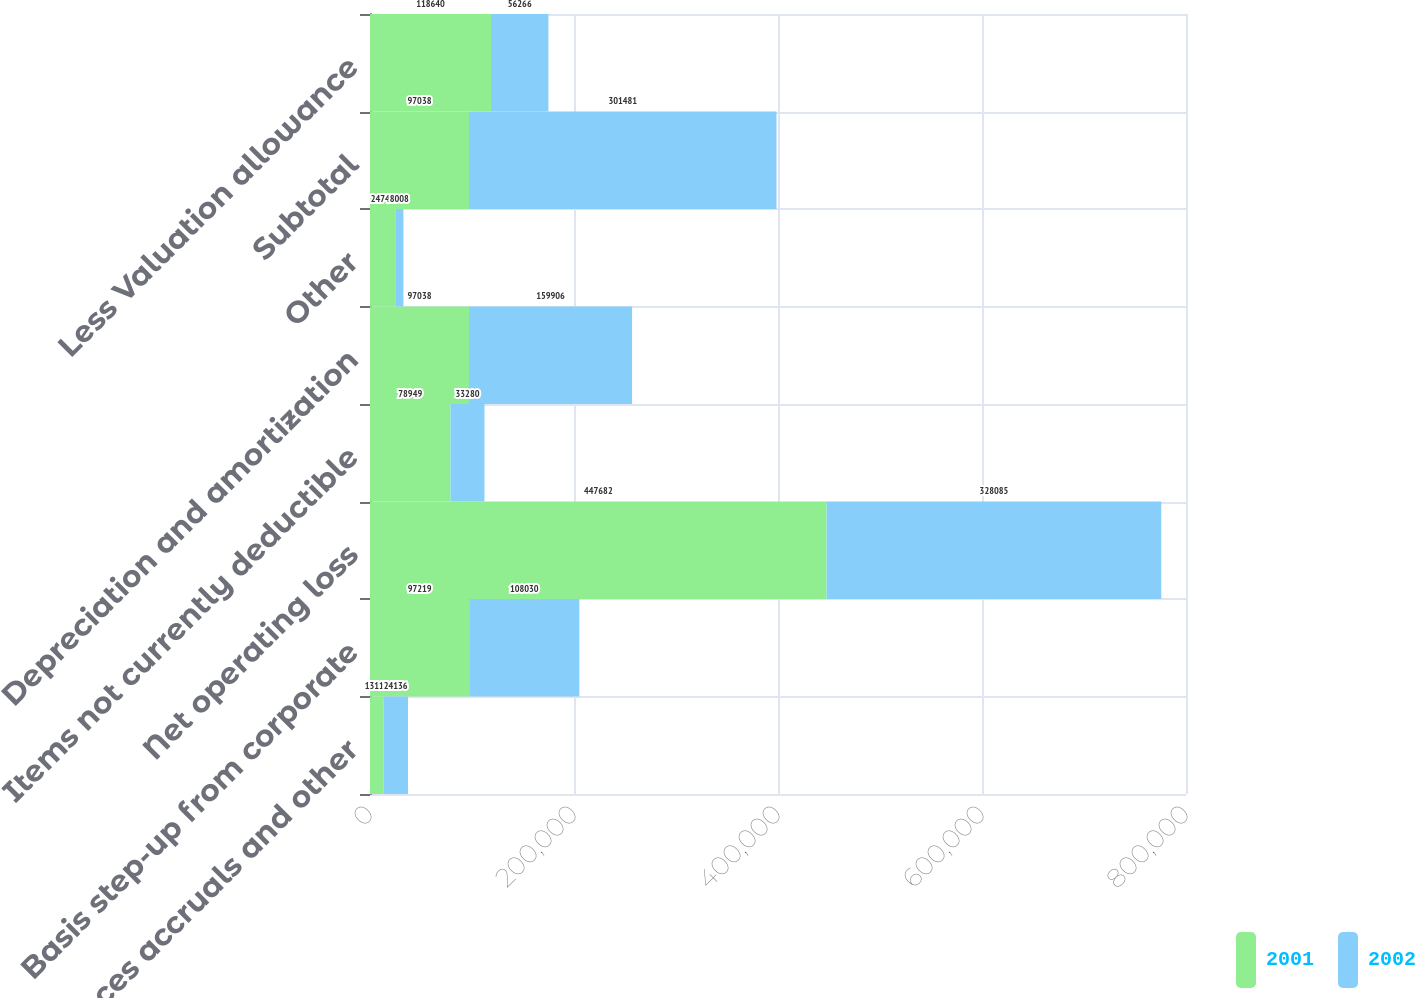Convert chart. <chart><loc_0><loc_0><loc_500><loc_500><stacked_bar_chart><ecel><fcel>Allowances accruals and other<fcel>Basis step-up from corporate<fcel>Net operating loss<fcel>Items not currently deductible<fcel>Depreciation and amortization<fcel>Other<fcel>Subtotal<fcel>Less Valuation allowance<nl><fcel>2001<fcel>13111<fcel>97219<fcel>447682<fcel>78949<fcel>97038<fcel>24741<fcel>97038<fcel>118640<nl><fcel>2002<fcel>24136<fcel>108030<fcel>328085<fcel>33280<fcel>159906<fcel>8008<fcel>301481<fcel>56266<nl></chart> 